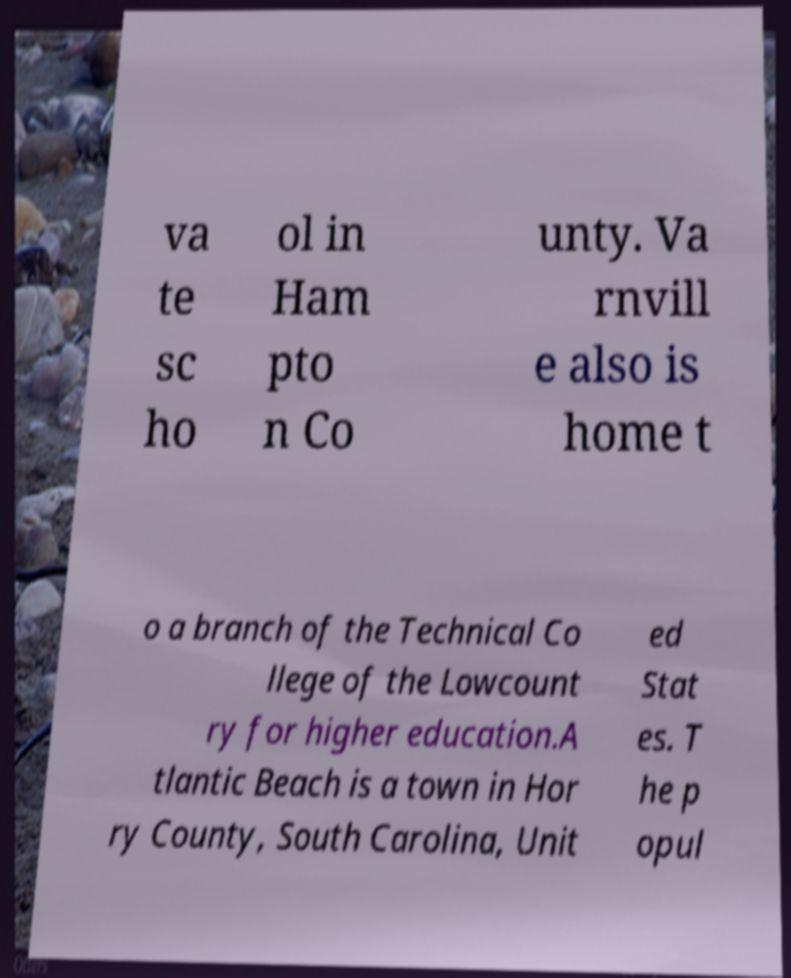What messages or text are displayed in this image? I need them in a readable, typed format. va te sc ho ol in Ham pto n Co unty. Va rnvill e also is home t o a branch of the Technical Co llege of the Lowcount ry for higher education.A tlantic Beach is a town in Hor ry County, South Carolina, Unit ed Stat es. T he p opul 